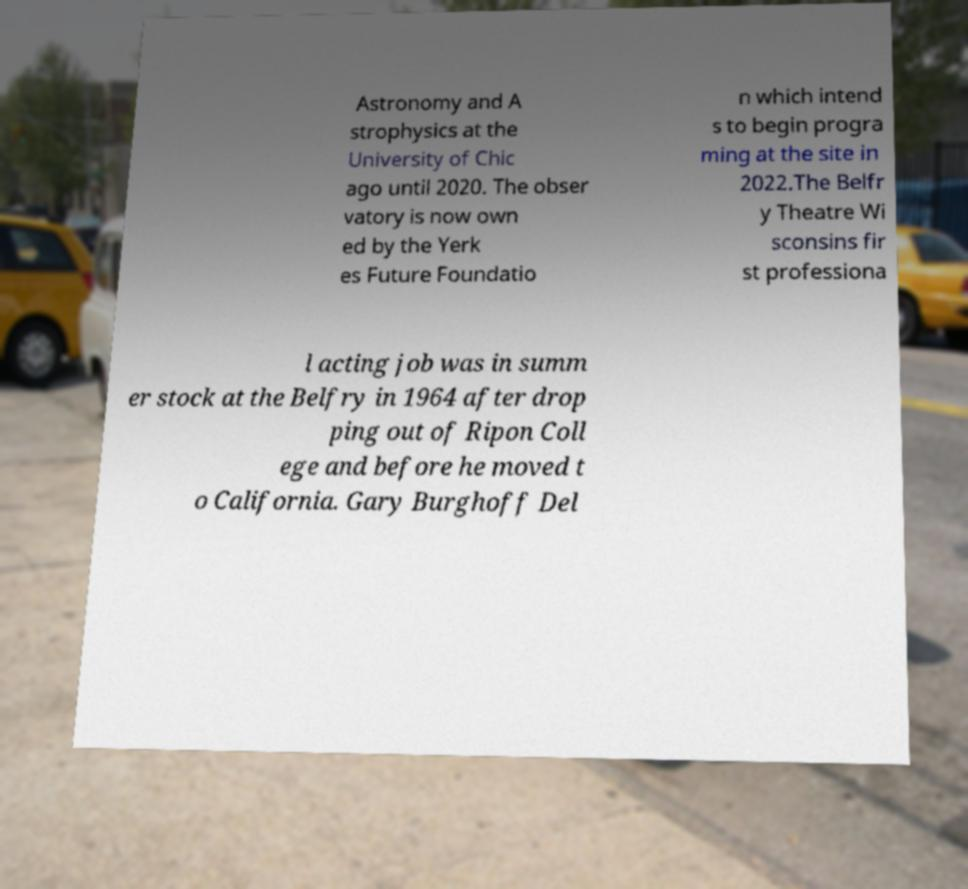Can you accurately transcribe the text from the provided image for me? Astronomy and A strophysics at the University of Chic ago until 2020. The obser vatory is now own ed by the Yerk es Future Foundatio n which intend s to begin progra ming at the site in 2022.The Belfr y Theatre Wi sconsins fir st professiona l acting job was in summ er stock at the Belfry in 1964 after drop ping out of Ripon Coll ege and before he moved t o California. Gary Burghoff Del 